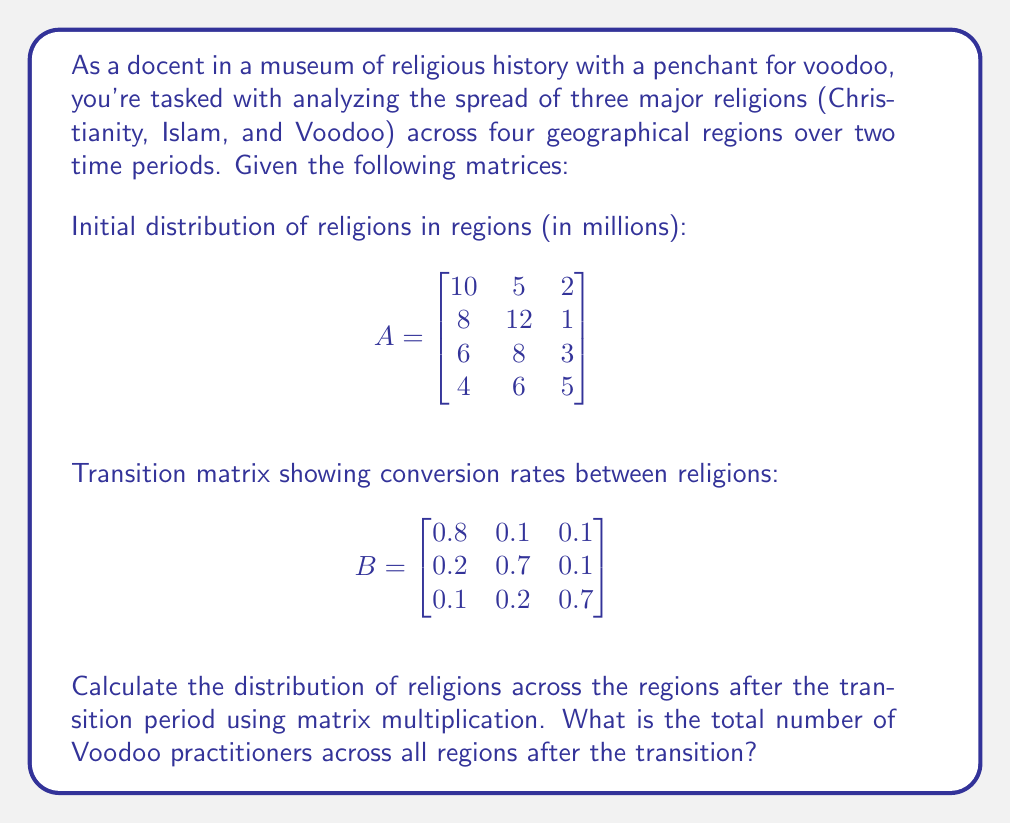What is the answer to this math problem? To solve this problem, we need to follow these steps:

1) First, we need to multiply matrix A by matrix B. This multiplication will give us the new distribution of religions across the regions after the transition period.

2) The resulting matrix C = A × B will have the same dimensions as matrix A (4×3).

3) Let's perform the matrix multiplication:

$$C = A \times B = \begin{bmatrix}
10 & 5 & 2 \\
8 & 12 & 1 \\
6 & 8 & 3 \\
4 & 6 & 5
\end{bmatrix} \times \begin{bmatrix}
0.8 & 0.1 & 0.1 \\
0.2 & 0.7 & 0.1 \\
0.1 & 0.2 & 0.7
\end{bmatrix}$$

4) Calculating each element of C:

$$c_{11} = 10(0.8) + 5(0.2) + 2(0.1) = 9$$
$$c_{12} = 10(0.1) + 5(0.7) + 2(0.2) = 4.9$$
$$c_{13} = 10(0.1) + 5(0.1) + 2(0.7) = 3.1$$

$$c_{21} = 8(0.8) + 12(0.2) + 1(0.1) = 9.1$$
$$c_{22} = 8(0.1) + 12(0.7) + 1(0.2) = 9.4$$
$$c_{23} = 8(0.1) + 12(0.1) + 1(0.7) = 2.5$$

$$c_{31} = 6(0.8) + 8(0.2) + 3(0.1) = 6.9$$
$$c_{32} = 6(0.1) + 8(0.7) + 3(0.2) = 6.6$$
$$c_{33} = 6(0.1) + 8(0.1) + 3(0.7) = 3.5$$

$$c_{41} = 4(0.8) + 6(0.2) + 5(0.1) = 4.7$$
$$c_{42} = 4(0.1) + 6(0.7) + 5(0.2) = 5.4$$
$$c_{43} = 4(0.1) + 6(0.1) + 5(0.7) = 4.9$$

5) The resulting matrix C is:

$$C = \begin{bmatrix}
9.0 & 4.9 & 3.1 \\
9.1 & 9.4 & 2.5 \\
6.9 & 6.6 & 3.5 \\
4.7 & 5.4 & 4.9
\end{bmatrix}$$

6) To find the total number of Voodoo practitioners, we sum the values in the third column of matrix C:

$3.1 + 2.5 + 3.5 + 4.9 = 14$

Therefore, the total number of Voodoo practitioners across all regions after the transition is 14 million.
Answer: 14 million 